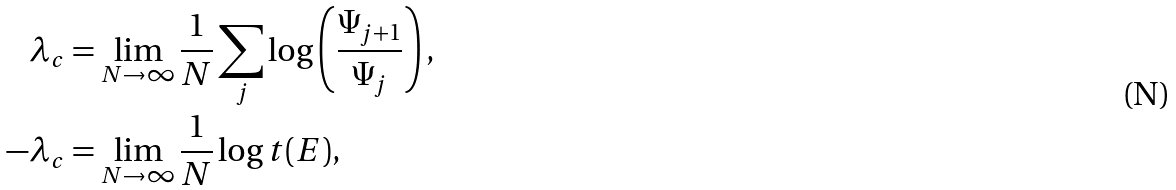Convert formula to latex. <formula><loc_0><loc_0><loc_500><loc_500>\lambda _ { c } & = \lim _ { N \rightarrow \infty } \frac { 1 } { N } \sum _ { j } \log \left ( \frac { \Psi _ { j + 1 } } { \Psi _ { j } } \right ) , \\ - \lambda _ { c } & = \lim _ { N \rightarrow \infty } \frac { 1 } { N } \log t ( E ) ,</formula> 